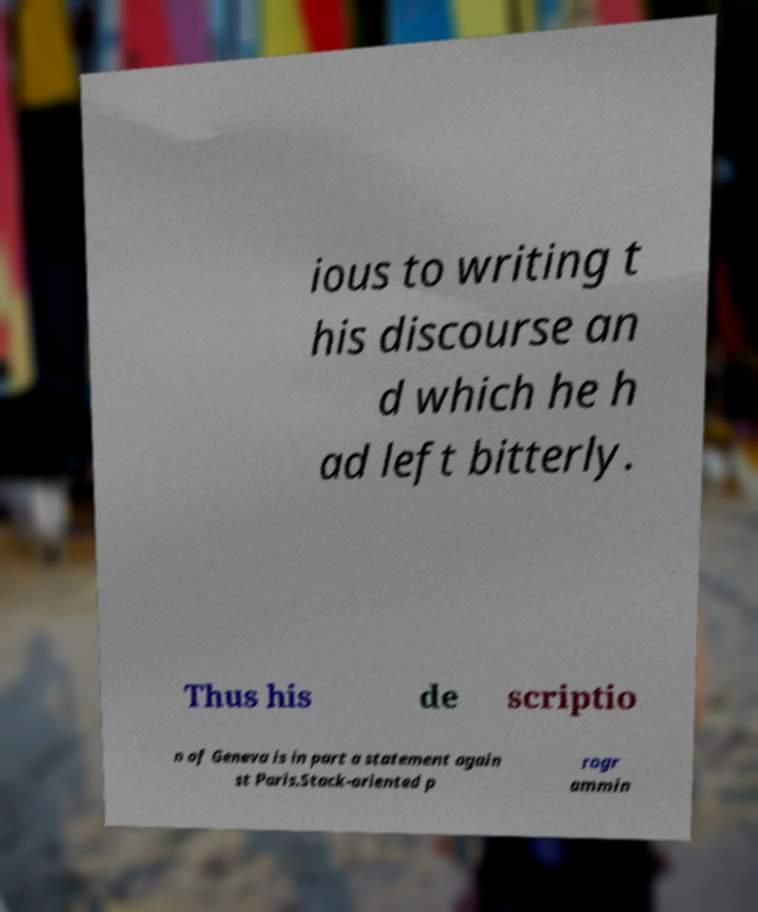Could you extract and type out the text from this image? ious to writing t his discourse an d which he h ad left bitterly. Thus his de scriptio n of Geneva is in part a statement again st Paris.Stack-oriented p rogr ammin 